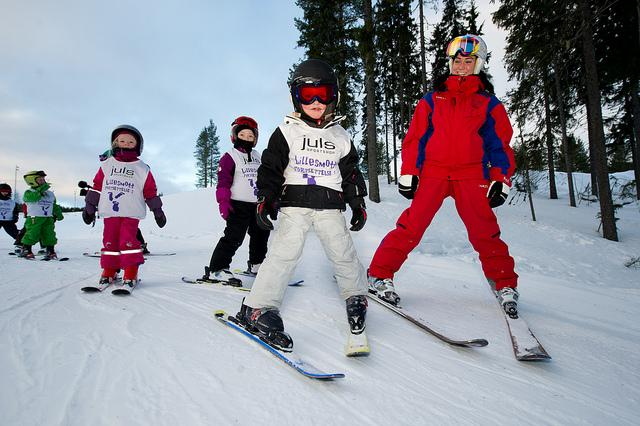Which person is the teacher?

Choices:
A) black pants
B) green clothes
C) red clothes
D) white pants red clothes 